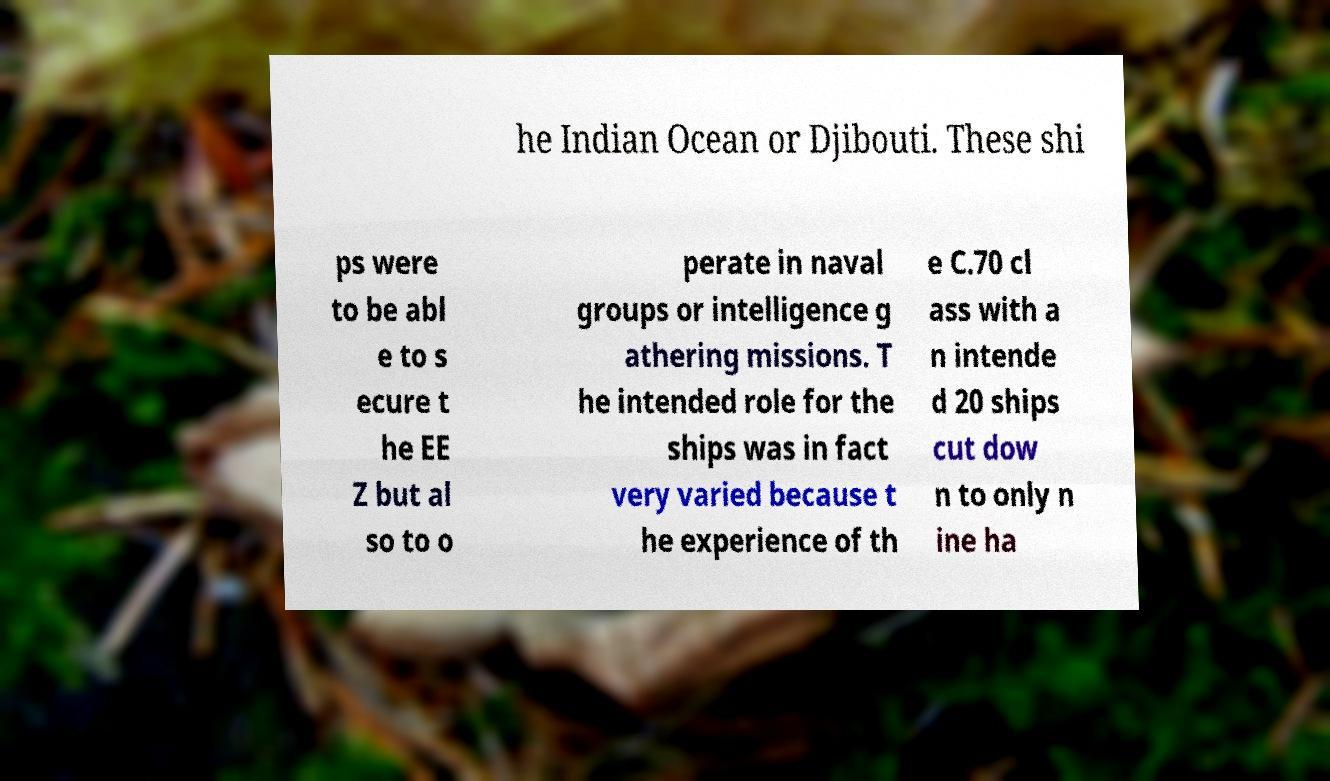Can you read and provide the text displayed in the image?This photo seems to have some interesting text. Can you extract and type it out for me? he Indian Ocean or Djibouti. These shi ps were to be abl e to s ecure t he EE Z but al so to o perate in naval groups or intelligence g athering missions. T he intended role for the ships was in fact very varied because t he experience of th e C.70 cl ass with a n intende d 20 ships cut dow n to only n ine ha 